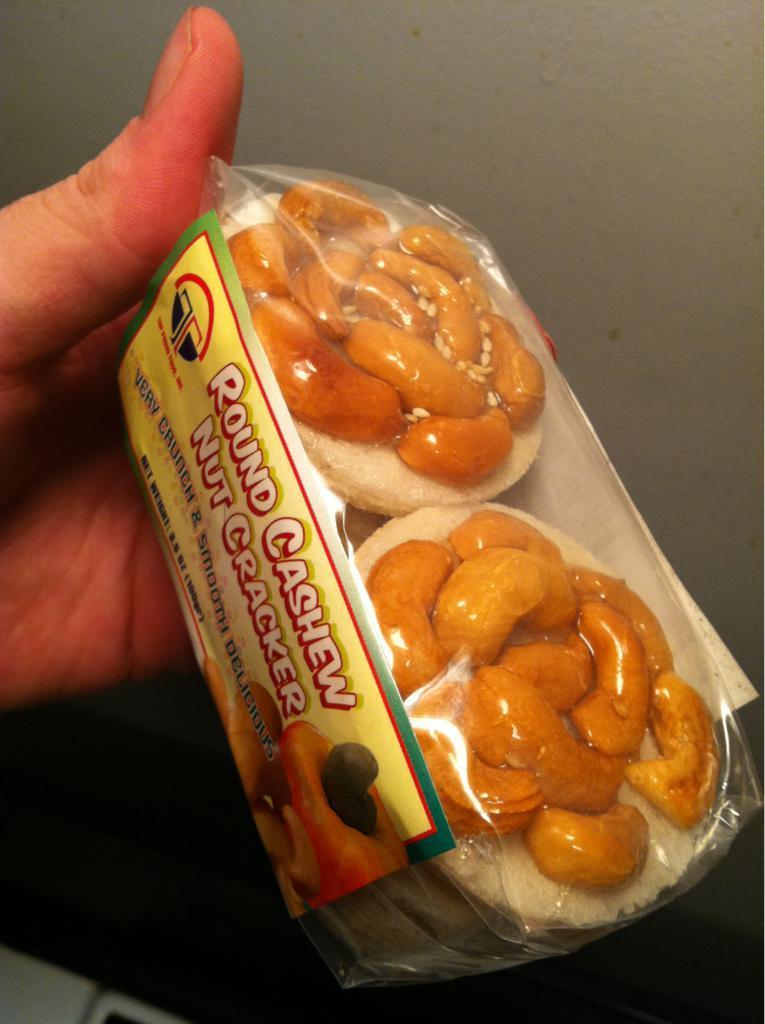How would you summarize this image in a sentence or two? The picture consists of a person's hand holding a food item. At the top it is well. 